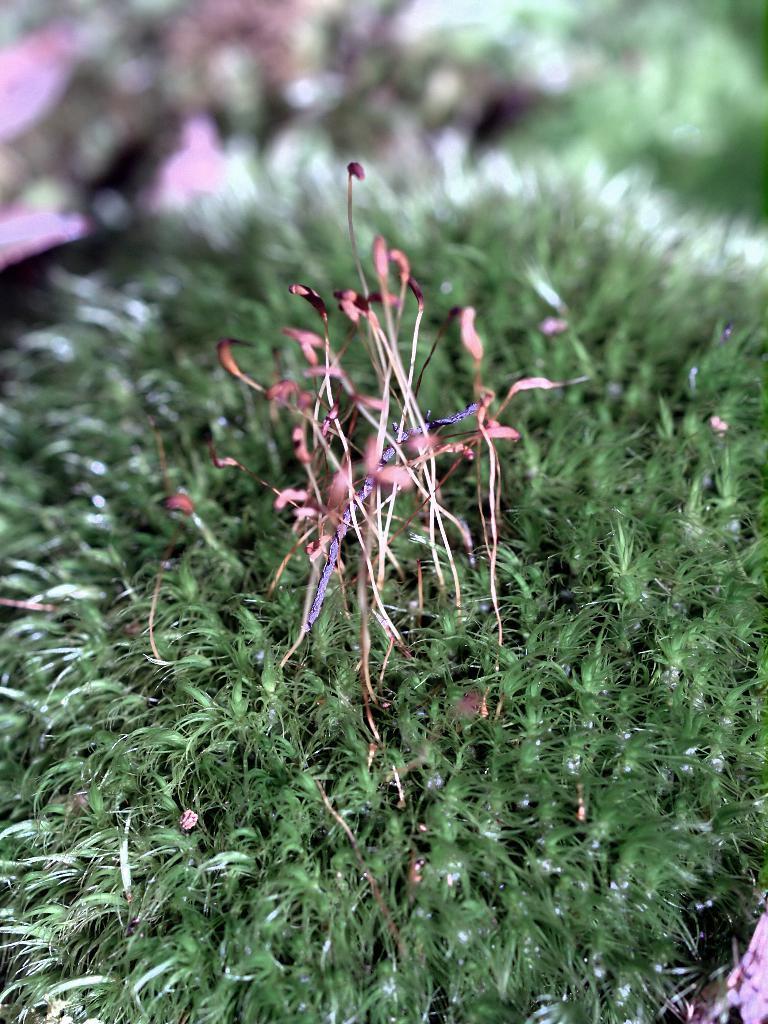Could you give a brief overview of what you see in this image? In this image we can see some plants. 